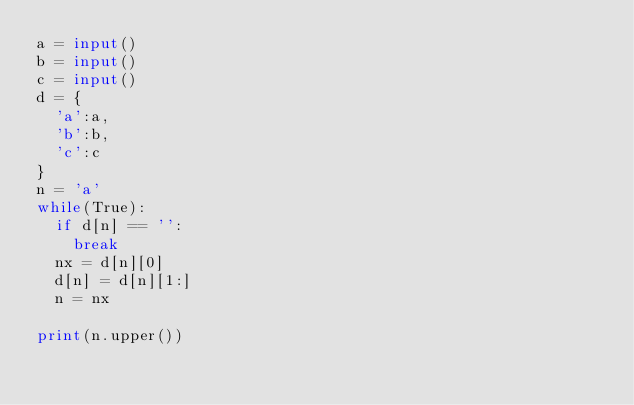Convert code to text. <code><loc_0><loc_0><loc_500><loc_500><_Python_>a = input()
b = input()
c = input()
d = {
  'a':a, 
  'b':b,
  'c':c
}
n = 'a'
while(True):
  if d[n] == '':
    break
  nx = d[n][0]
  d[n] = d[n][1:]
  n = nx

print(n.upper())</code> 